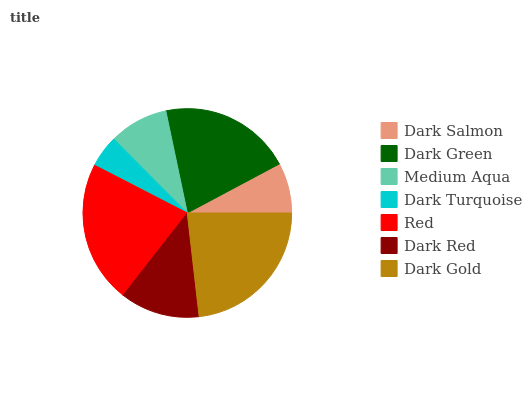Is Dark Turquoise the minimum?
Answer yes or no. Yes. Is Dark Gold the maximum?
Answer yes or no. Yes. Is Dark Green the minimum?
Answer yes or no. No. Is Dark Green the maximum?
Answer yes or no. No. Is Dark Green greater than Dark Salmon?
Answer yes or no. Yes. Is Dark Salmon less than Dark Green?
Answer yes or no. Yes. Is Dark Salmon greater than Dark Green?
Answer yes or no. No. Is Dark Green less than Dark Salmon?
Answer yes or no. No. Is Dark Red the high median?
Answer yes or no. Yes. Is Dark Red the low median?
Answer yes or no. Yes. Is Medium Aqua the high median?
Answer yes or no. No. Is Dark Turquoise the low median?
Answer yes or no. No. 